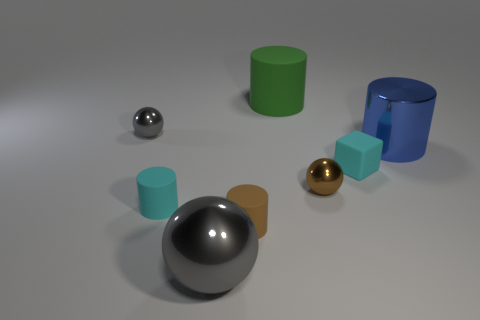Subtract all tiny gray balls. How many balls are left? 2 Add 1 small objects. How many objects exist? 9 Subtract all brown balls. How many balls are left? 2 Subtract 2 balls. How many balls are left? 1 Subtract all cyan cubes. How many gray spheres are left? 2 Subtract all spheres. How many objects are left? 5 Subtract all tiny gray balls. Subtract all brown spheres. How many objects are left? 6 Add 5 green things. How many green things are left? 6 Add 6 tiny yellow shiny objects. How many tiny yellow shiny objects exist? 6 Subtract 0 yellow spheres. How many objects are left? 8 